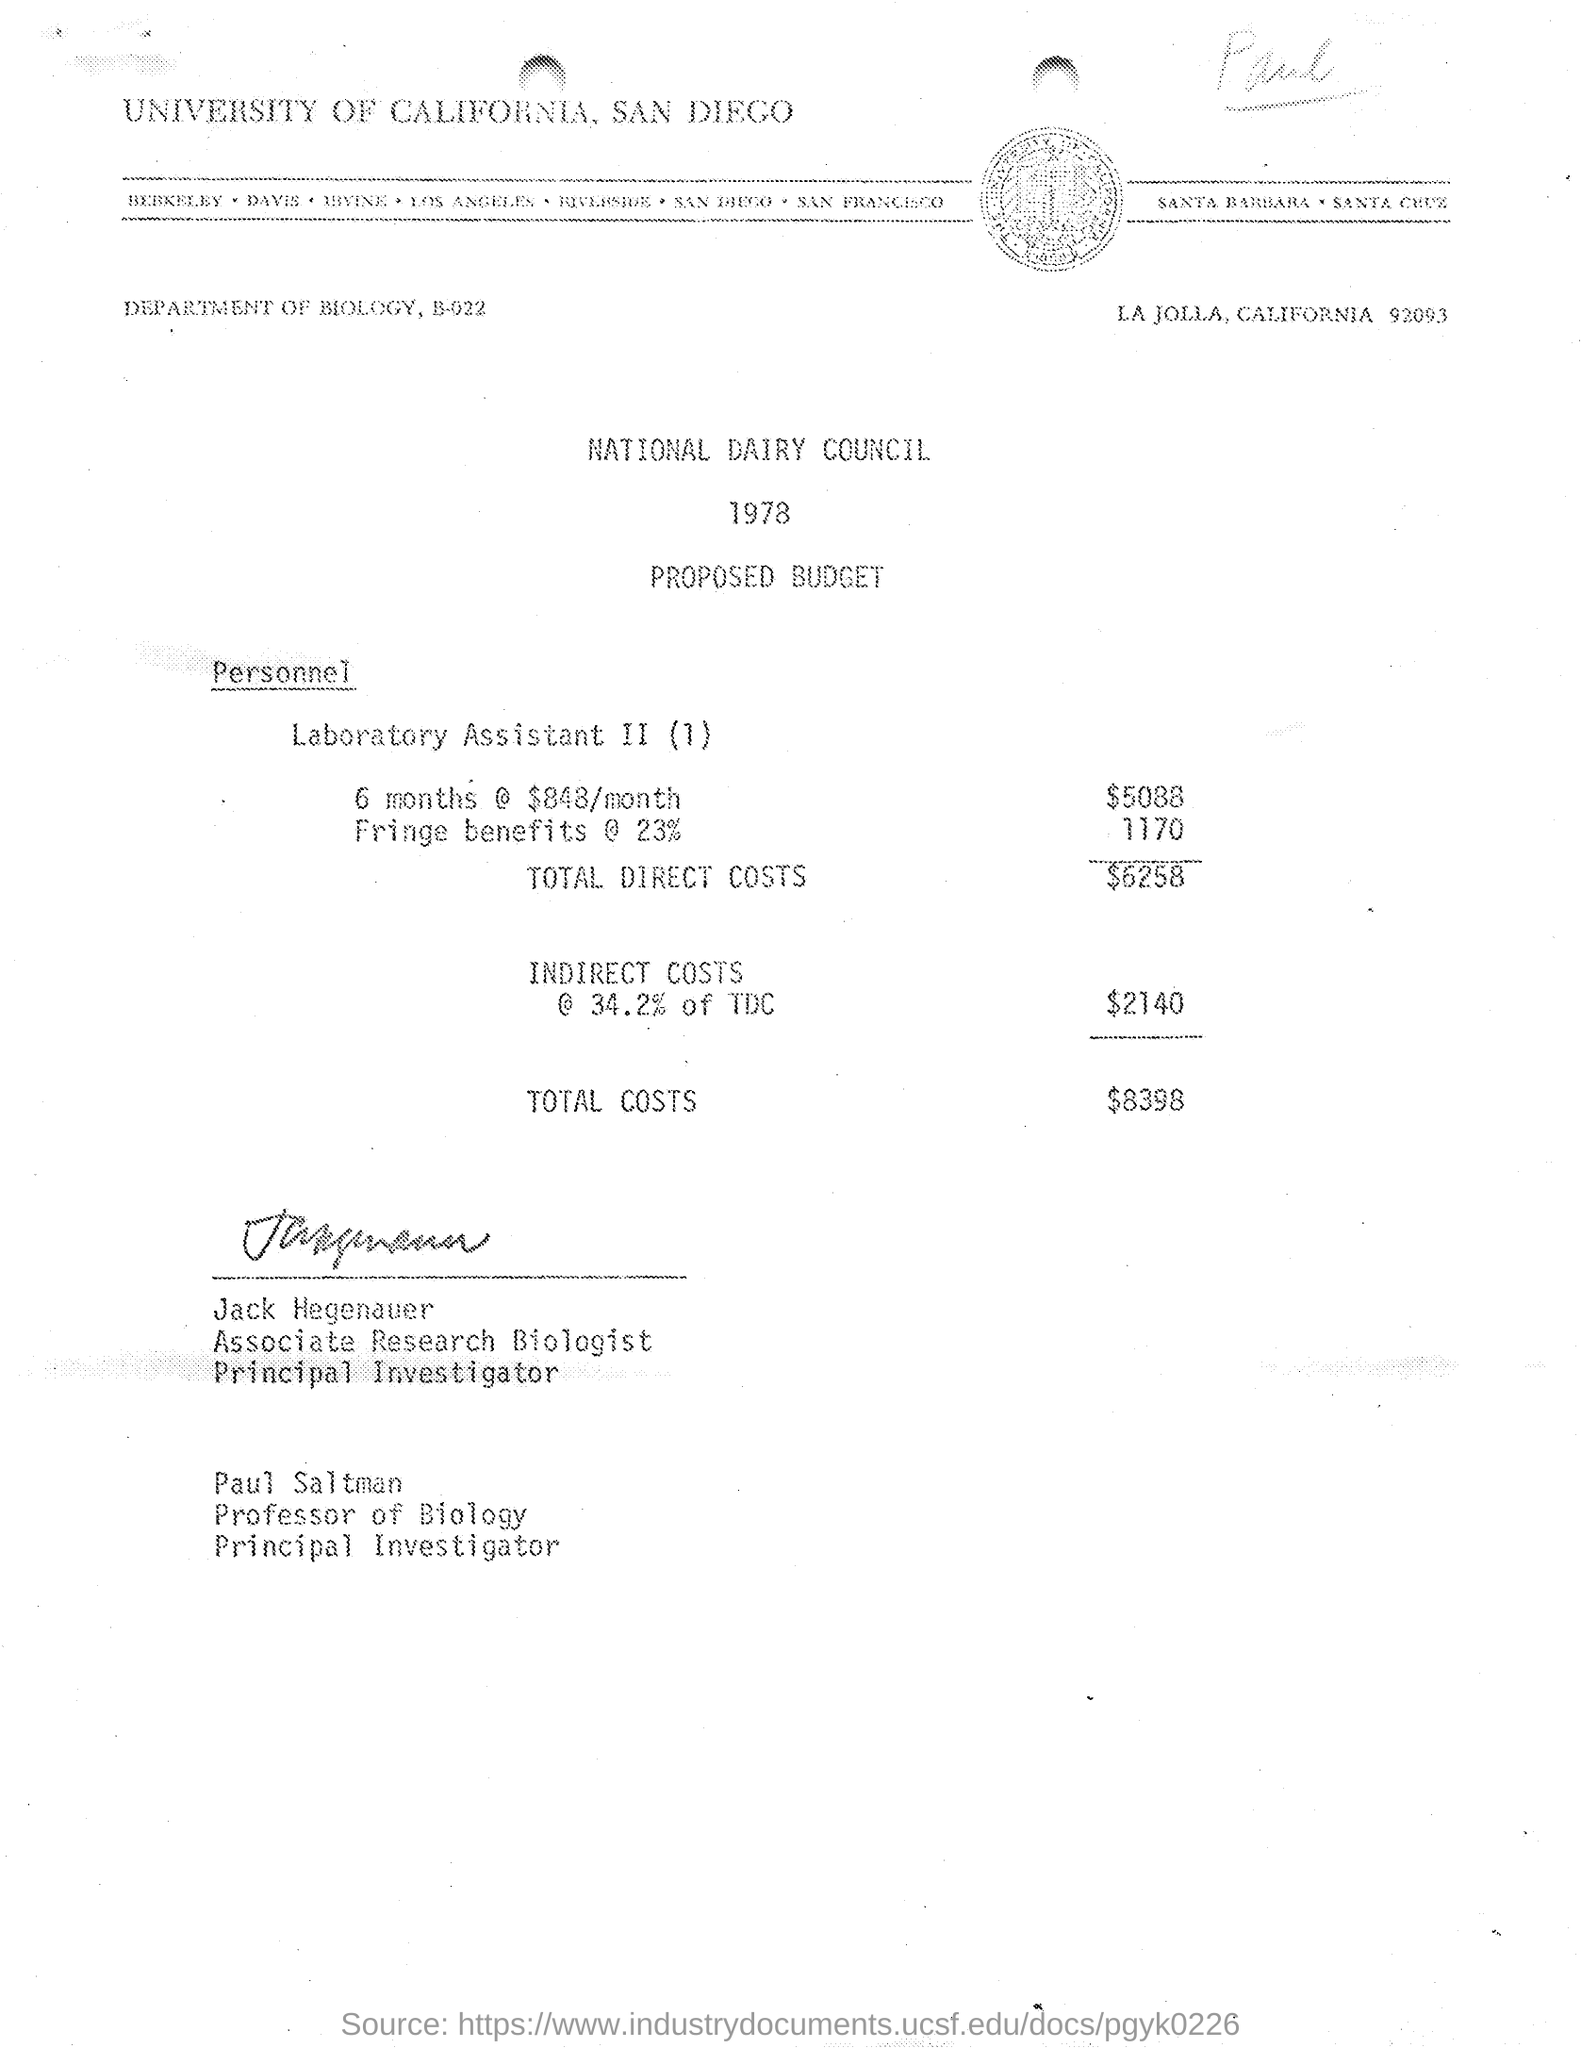Mention a couple of crucial points in this snapshot. The monthly paid amount is $848. The fringe benefit taken here is approximately 23%. The proposed budget was presented in the year 1978. The budget for Laboratory Assistants for a period of 6 months is $5088. Jack Hegenauer was an Associate Research Biologist. 